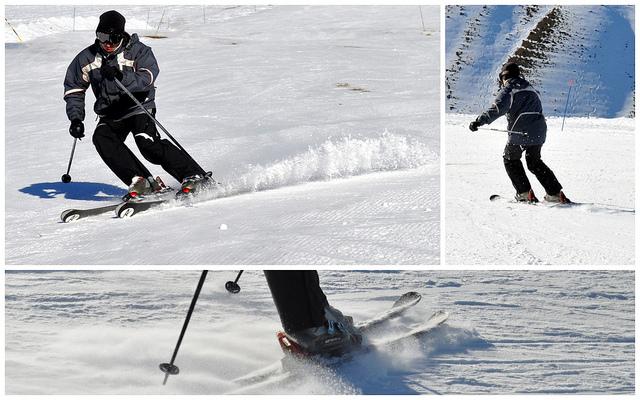Is the skier using poles?
Short answer required. Yes. Is the skier wearing goggles?
Short answer required. Yes. Is it cold outside?
Short answer required. Yes. 